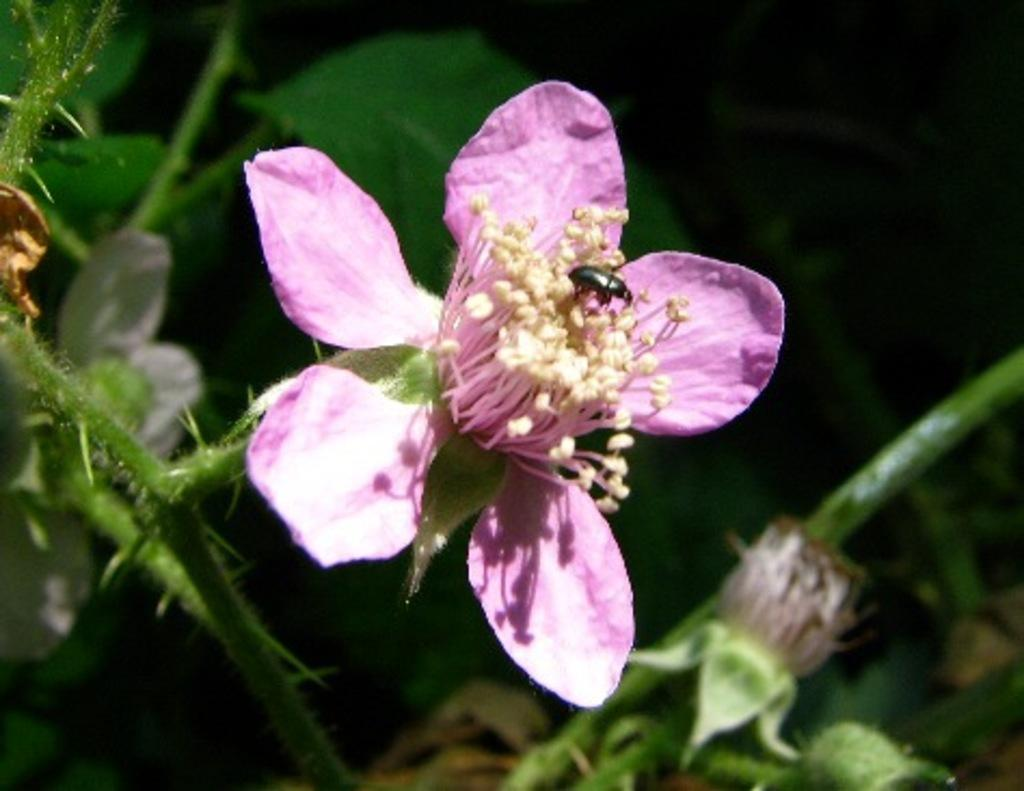What is the main subject of the image? The main subject of the image is a bee. Where is the bee located in the image? The bee is sitting on a flower. What is the flower attached to in the image? The flower is on a plant. What type of discussion is taking place between the bee and the butter in the image? There is no butter present in the image, and therefore no discussion can be observed between the bee and the butter. 